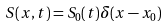Convert formula to latex. <formula><loc_0><loc_0><loc_500><loc_500>S ( x , t ) = S _ { 0 } ( t ) \delta ( x - x _ { 0 } )</formula> 